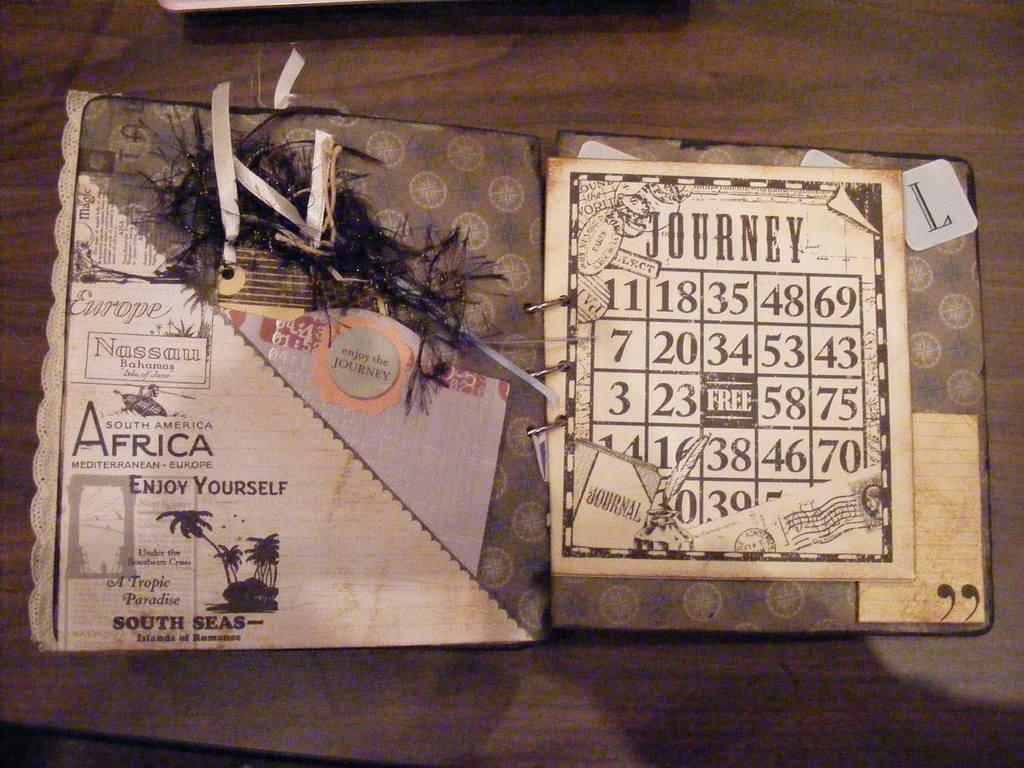<image>
Summarize the visual content of the image. a binder opened to a page reading Journey with numbers below it 